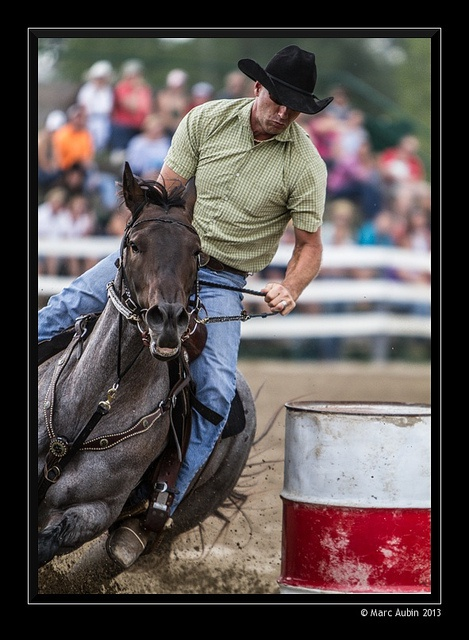Describe the objects in this image and their specific colors. I can see horse in black, gray, and darkgray tones, people in black, darkgray, and gray tones, people in black, brown, lightpink, darkgray, and navy tones, people in black, darkgray, brown, lightpink, and gray tones, and people in black, lavender, darkgray, and gray tones in this image. 